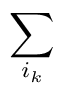<formula> <loc_0><loc_0><loc_500><loc_500>\sum _ { i _ { k } }</formula> 